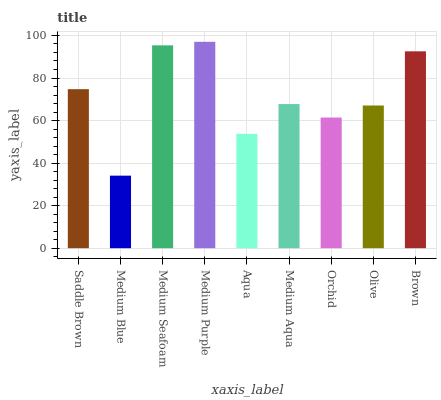Is Medium Seafoam the minimum?
Answer yes or no. No. Is Medium Seafoam the maximum?
Answer yes or no. No. Is Medium Seafoam greater than Medium Blue?
Answer yes or no. Yes. Is Medium Blue less than Medium Seafoam?
Answer yes or no. Yes. Is Medium Blue greater than Medium Seafoam?
Answer yes or no. No. Is Medium Seafoam less than Medium Blue?
Answer yes or no. No. Is Medium Aqua the high median?
Answer yes or no. Yes. Is Medium Aqua the low median?
Answer yes or no. Yes. Is Medium Seafoam the high median?
Answer yes or no. No. Is Medium Purple the low median?
Answer yes or no. No. 